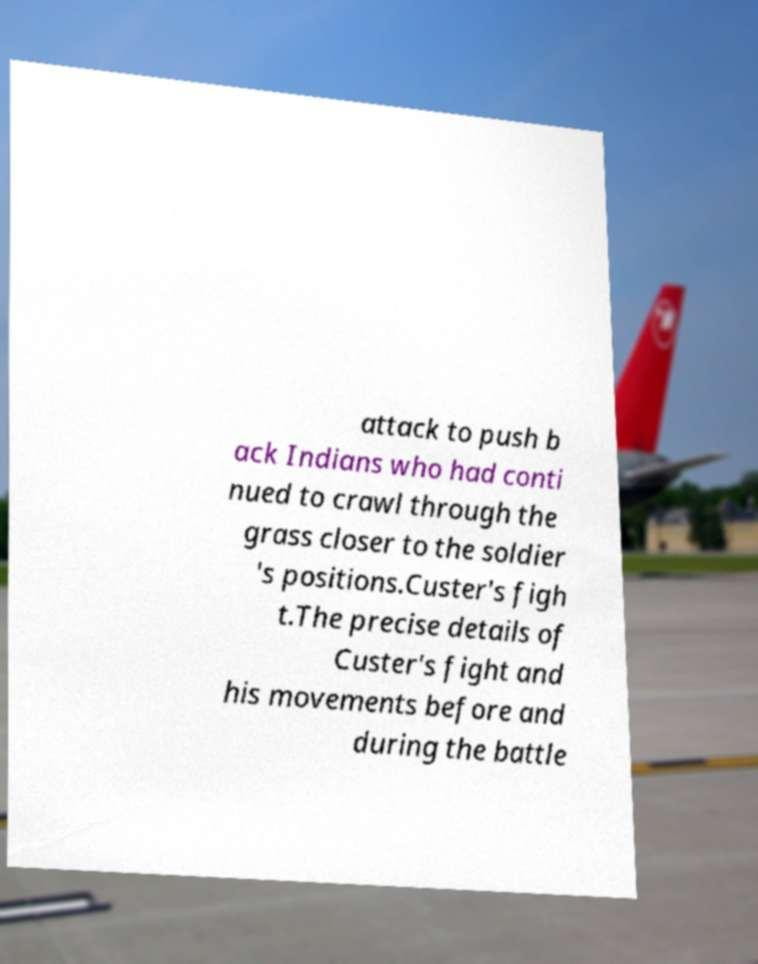Can you accurately transcribe the text from the provided image for me? attack to push b ack Indians who had conti nued to crawl through the grass closer to the soldier 's positions.Custer's figh t.The precise details of Custer's fight and his movements before and during the battle 